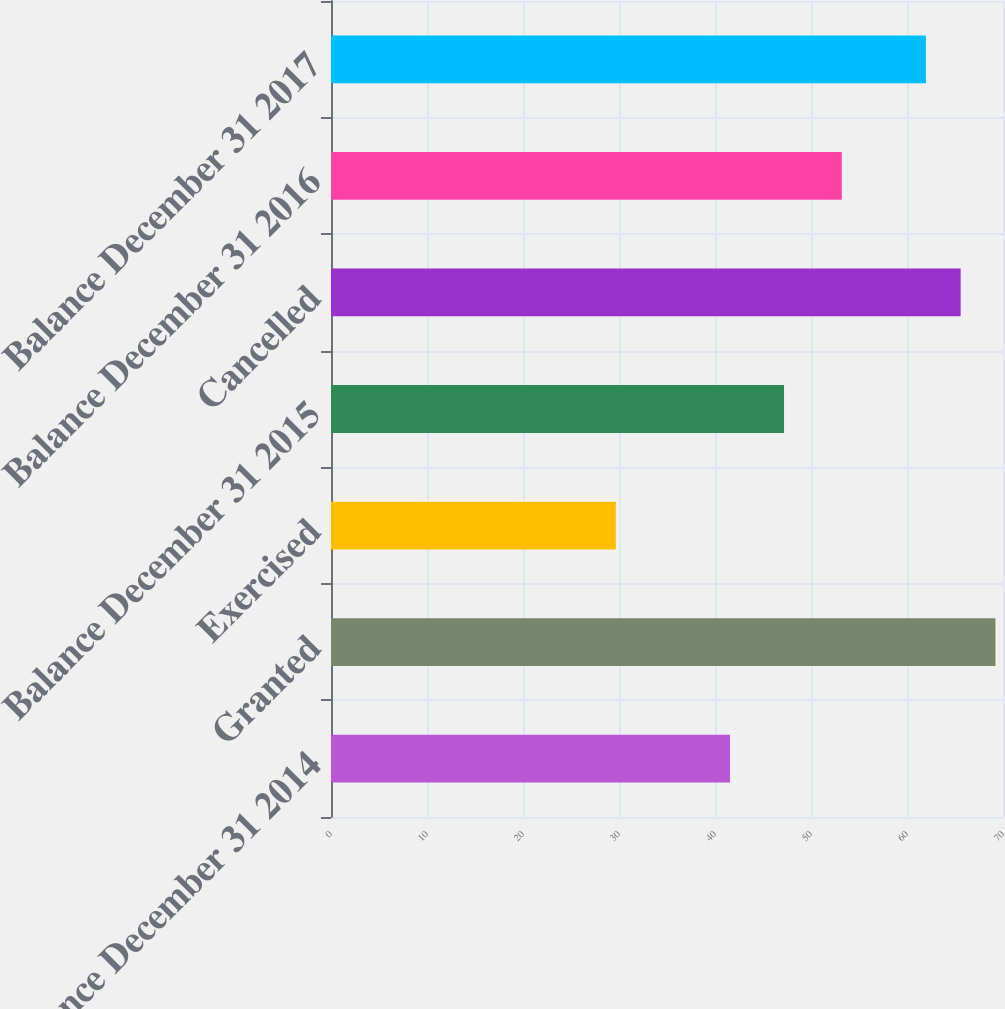Convert chart. <chart><loc_0><loc_0><loc_500><loc_500><bar_chart><fcel>Balance December 31 2014<fcel>Granted<fcel>Exercised<fcel>Balance December 31 2015<fcel>Cancelled<fcel>Balance December 31 2016<fcel>Balance December 31 2017<nl><fcel>41.56<fcel>69.21<fcel>29.67<fcel>47.19<fcel>65.59<fcel>53.21<fcel>61.97<nl></chart> 